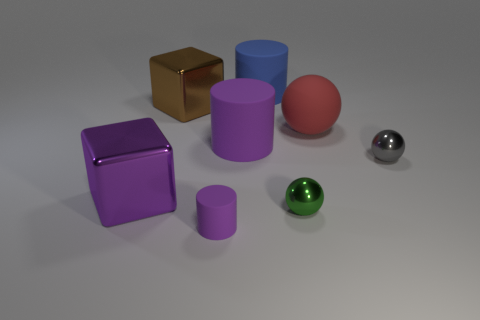What insights can you draw about the lighting used in this scene? The lighting in this scene is soft and diffuse, with muted shadows suggesting an evenly spread light source. The lack of harsh shadows or bright highlights indicates that the environment may not have a direct spotlight but rather ambient light illuminating the room. This provides a calm and clear view of the objects with minimal glare. Is there anything about the shadows that tells us more about the light direction? Yes, the direction of the shadows can provide clues about the light source's position. Judging by the shadows casted by the objects, the light seems to be coming from the upper left corner of the scene. The shadows extend towards the right, indicating the light source is not directly above the objects but somewhat angled. 